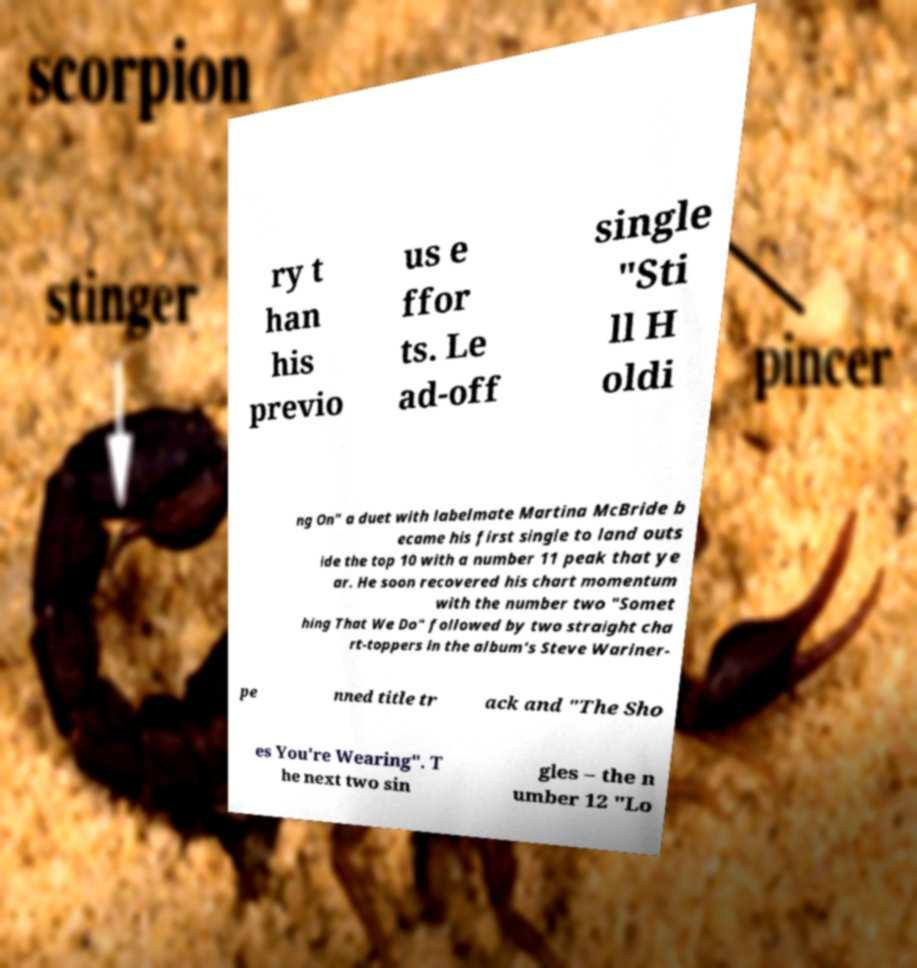I need the written content from this picture converted into text. Can you do that? ry t han his previo us e ffor ts. Le ad-off single "Sti ll H oldi ng On" a duet with labelmate Martina McBride b ecame his first single to land outs ide the top 10 with a number 11 peak that ye ar. He soon recovered his chart momentum with the number two "Somet hing That We Do" followed by two straight cha rt-toppers in the album's Steve Wariner- pe nned title tr ack and "The Sho es You're Wearing". T he next two sin gles – the n umber 12 "Lo 